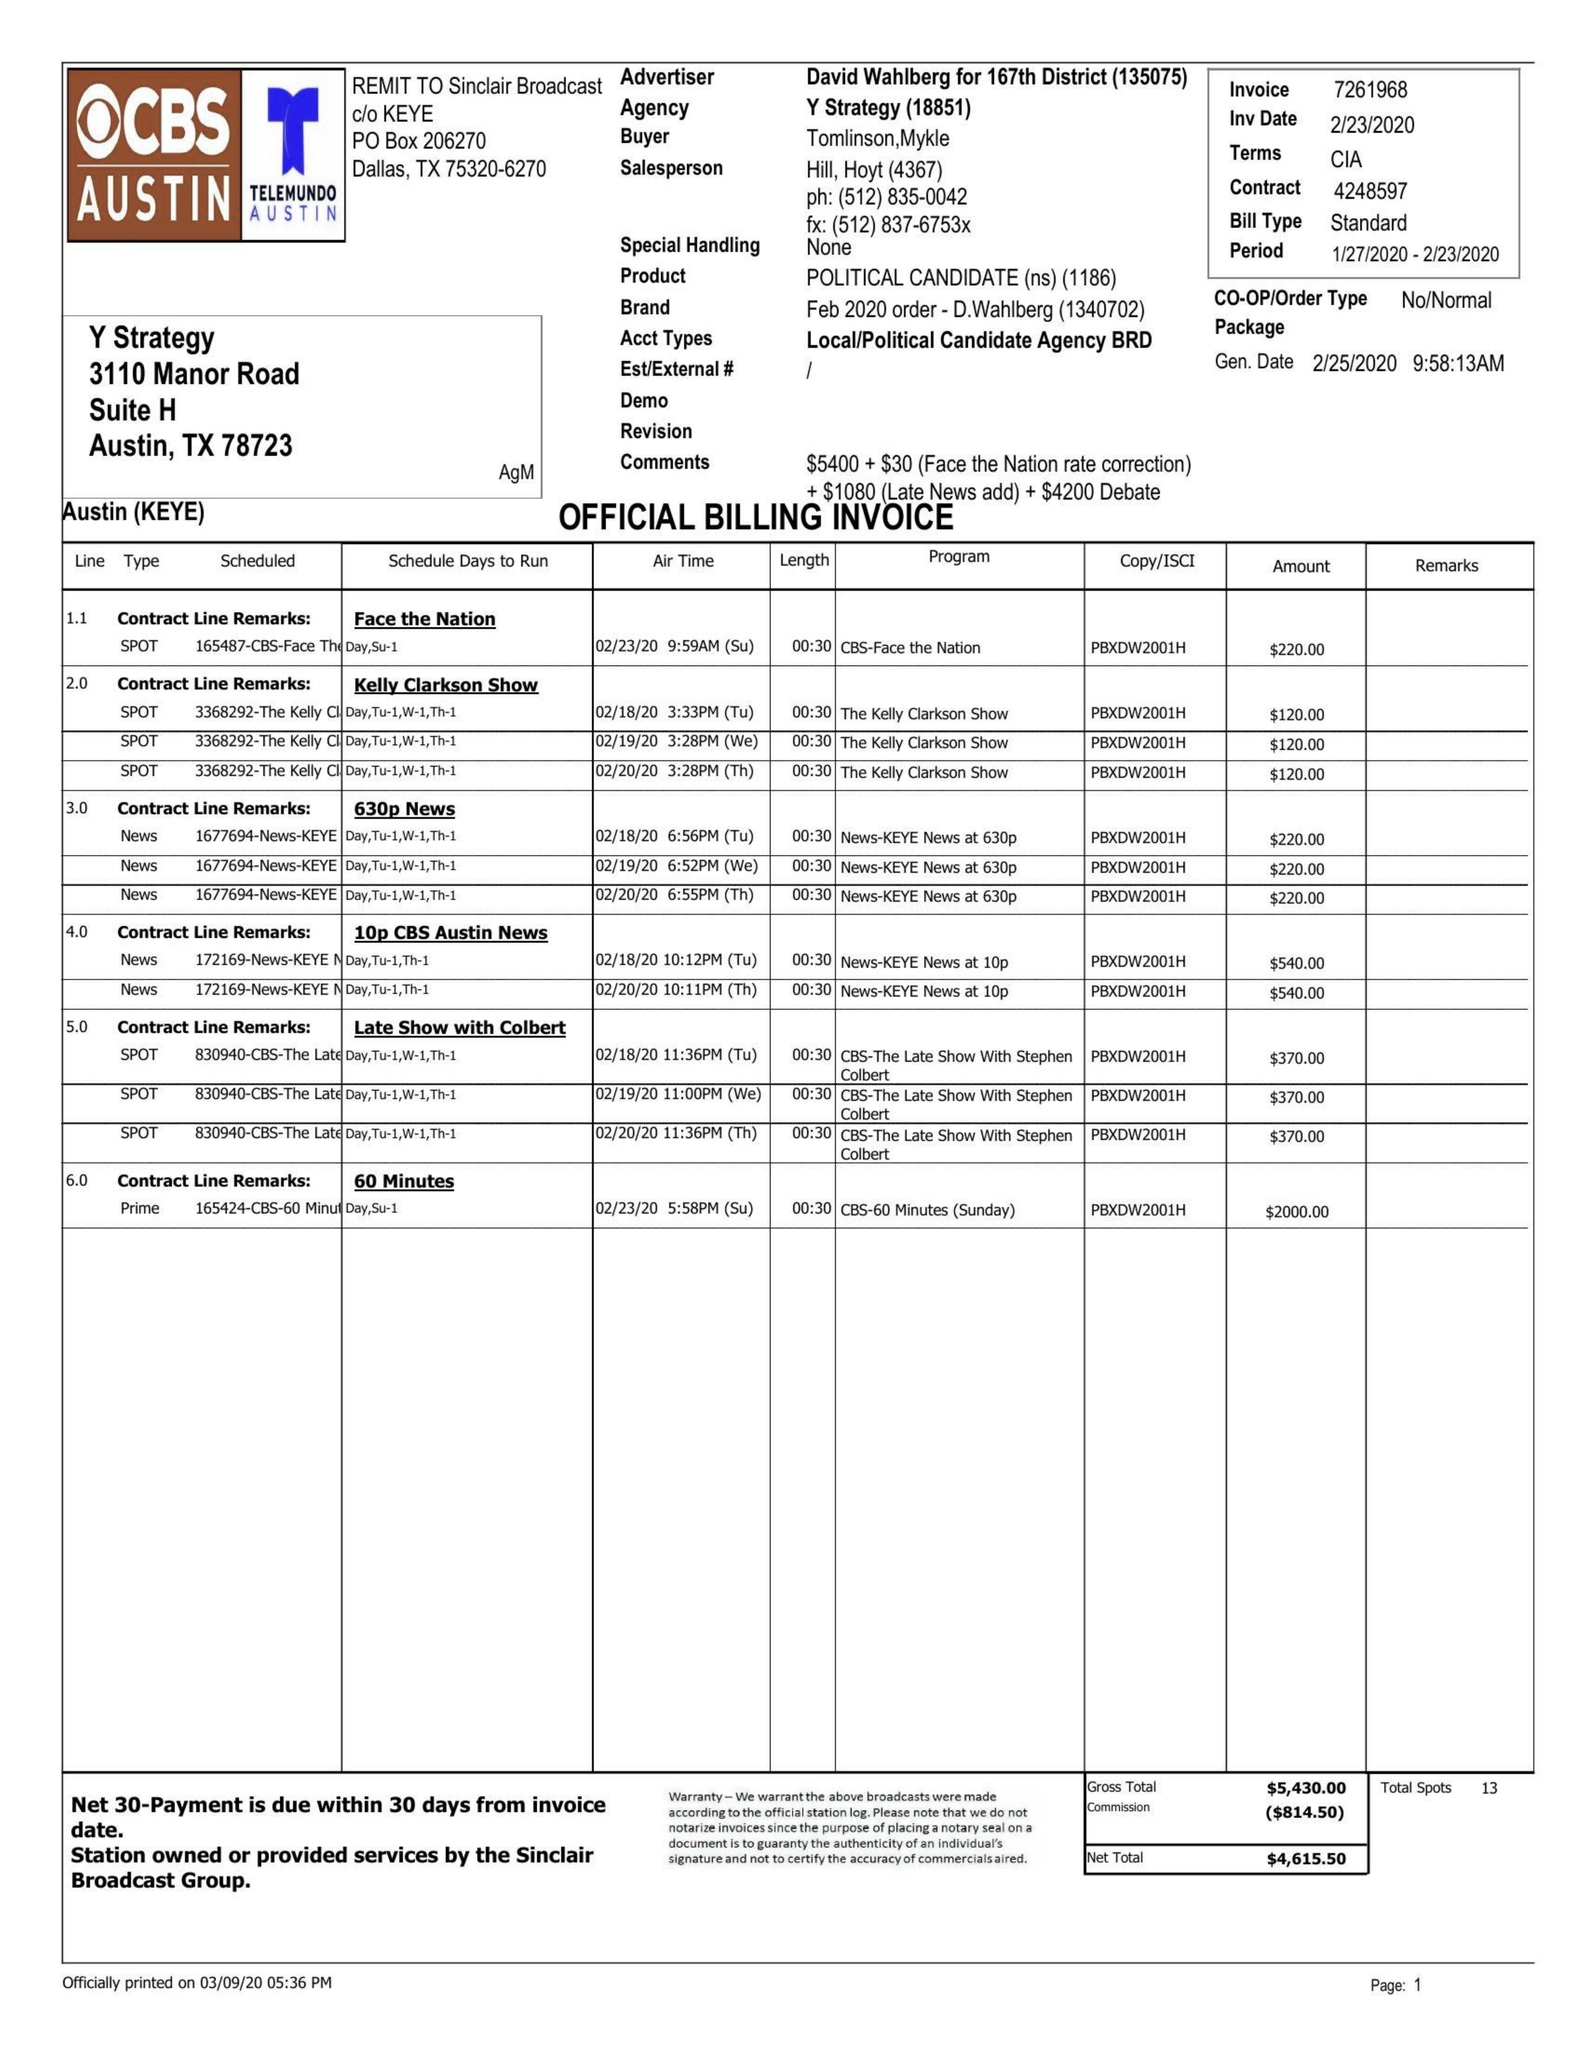What is the value for the advertiser?
Answer the question using a single word or phrase. DAVID WAHLBERG FOR 167TH DISTRICT 